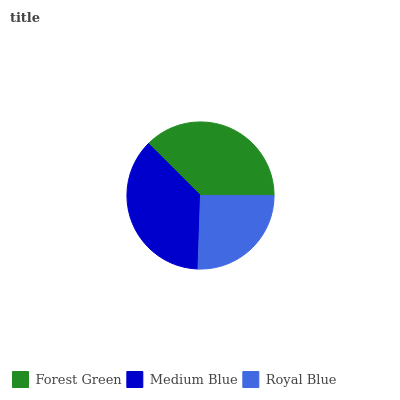Is Royal Blue the minimum?
Answer yes or no. Yes. Is Forest Green the maximum?
Answer yes or no. Yes. Is Medium Blue the minimum?
Answer yes or no. No. Is Medium Blue the maximum?
Answer yes or no. No. Is Forest Green greater than Medium Blue?
Answer yes or no. Yes. Is Medium Blue less than Forest Green?
Answer yes or no. Yes. Is Medium Blue greater than Forest Green?
Answer yes or no. No. Is Forest Green less than Medium Blue?
Answer yes or no. No. Is Medium Blue the high median?
Answer yes or no. Yes. Is Medium Blue the low median?
Answer yes or no. Yes. Is Royal Blue the high median?
Answer yes or no. No. Is Forest Green the low median?
Answer yes or no. No. 